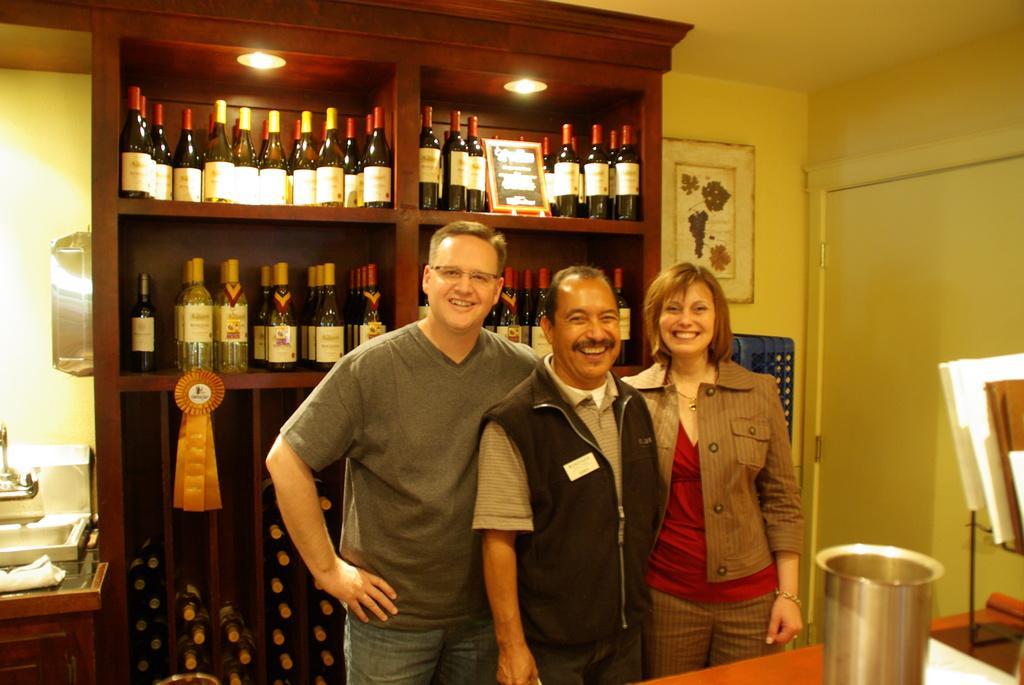Can you describe this image briefly? The image is taken inside a room. There are three people standing in the center of the image. In the background there is a shelf which contains bottles. To the left side of the image there is a table. On the right side there is a glass which is placed on a table and there are also some books placed on a shelf. 